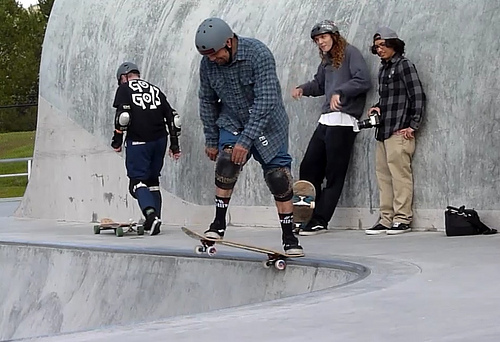How many people are walking away? Upon reviewing the image, it appears that there is one individual who is in motion on a skateboard, which might be interpreted as walking away. However, the term 'walking away' typically implies pedestrian movement, which is not the case here. Instead, it would be more accurate to describe the action as skateboarding away from the camera. 